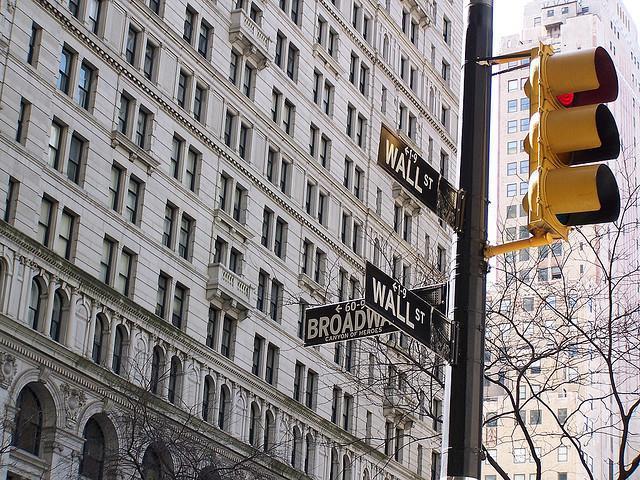How many traffic lights are visible?
Give a very brief answer. 1. 